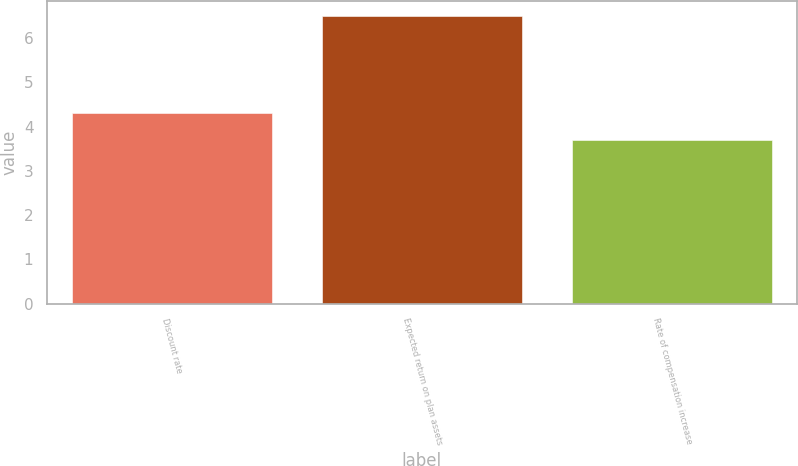Convert chart. <chart><loc_0><loc_0><loc_500><loc_500><bar_chart><fcel>Discount rate<fcel>Expected return on plan assets<fcel>Rate of compensation increase<nl><fcel>4.3<fcel>6.5<fcel>3.7<nl></chart> 